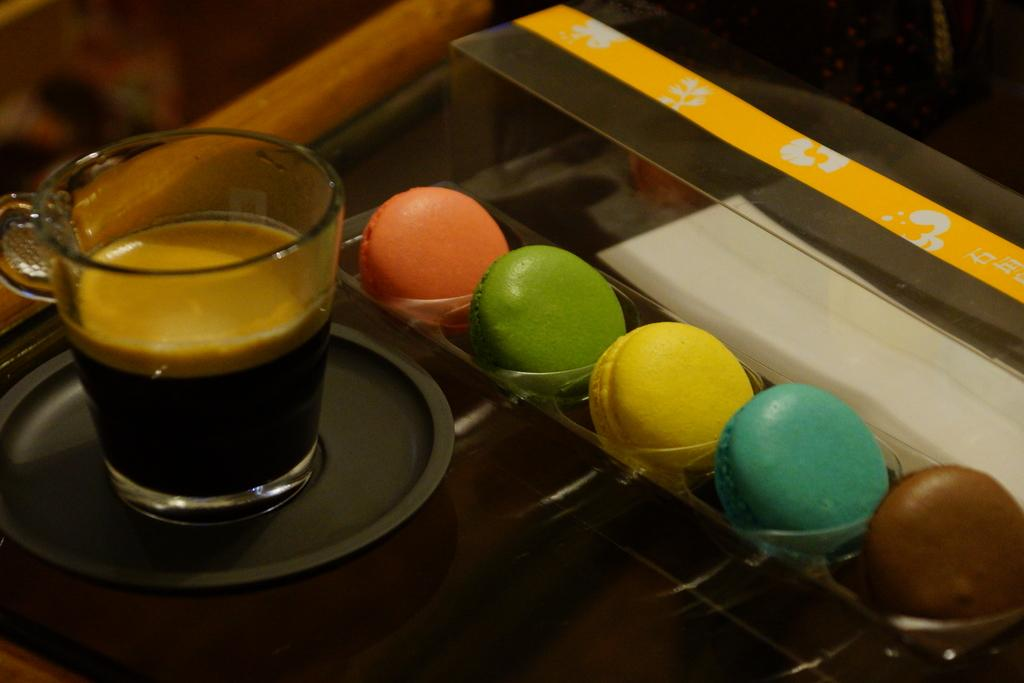What is in the glass that is visible in the image? There is a glass with coffee in the image. What type of cake is present in the image? There are bundt cakes in the image. How are the bundt cakes stored in the image? The bundt cakes are kept in a box. What other dishware can be seen in the image? There is a cup on a plate in the image. What type of cloud is visible in the image? There are no clouds visible in the image; it is an indoor scene with a glass of coffee, bundt cakes, and a cup on a plate. 